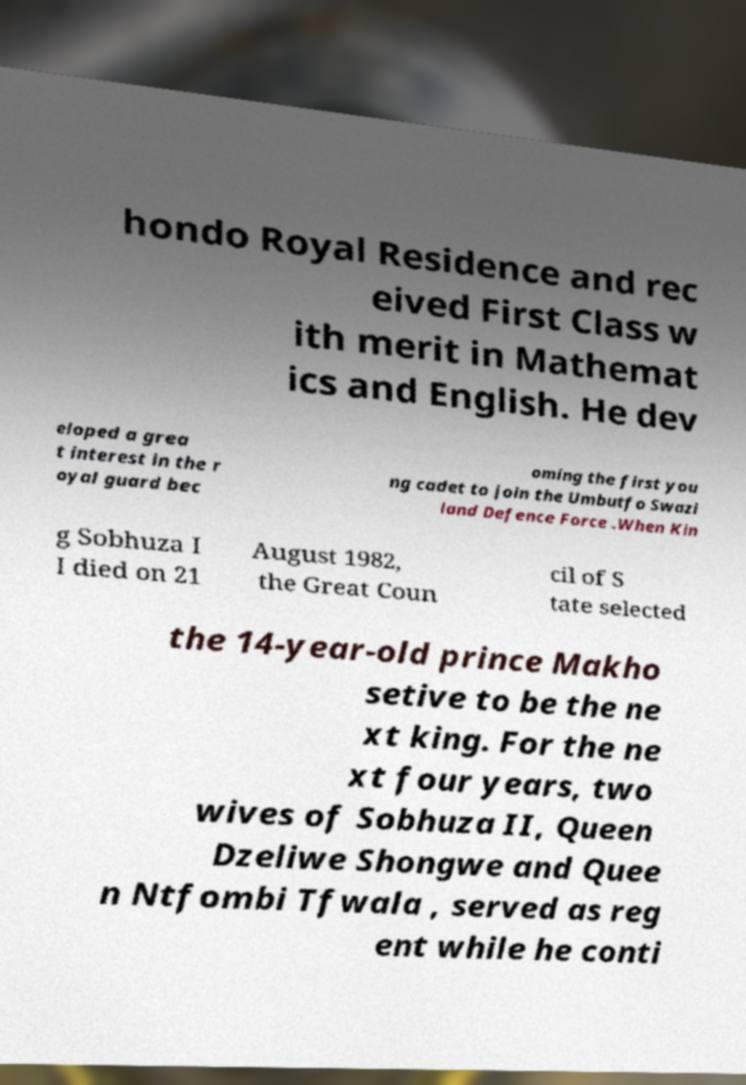I need the written content from this picture converted into text. Can you do that? hondo Royal Residence and rec eived First Class w ith merit in Mathemat ics and English. He dev eloped a grea t interest in the r oyal guard bec oming the first you ng cadet to join the Umbutfo Swazi land Defence Force .When Kin g Sobhuza I I died on 21 August 1982, the Great Coun cil of S tate selected the 14-year-old prince Makho setive to be the ne xt king. For the ne xt four years, two wives of Sobhuza II, Queen Dzeliwe Shongwe and Quee n Ntfombi Tfwala , served as reg ent while he conti 